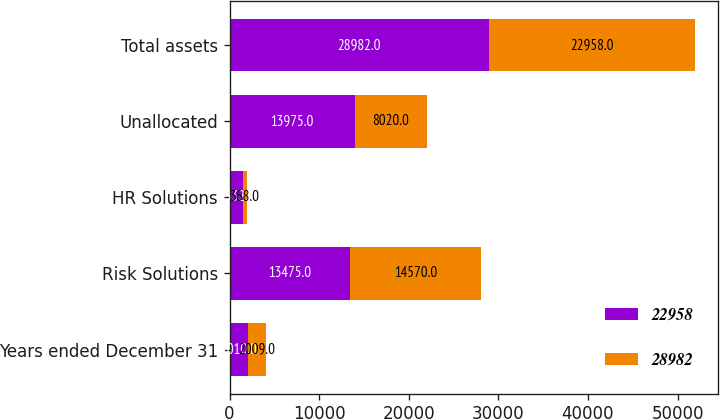Convert chart to OTSL. <chart><loc_0><loc_0><loc_500><loc_500><stacked_bar_chart><ecel><fcel>Years ended December 31<fcel>Risk Solutions<fcel>HR Solutions<fcel>Unallocated<fcel>Total assets<nl><fcel>22958<fcel>2010<fcel>13475<fcel>1532<fcel>13975<fcel>28982<nl><fcel>28982<fcel>2009<fcel>14570<fcel>368<fcel>8020<fcel>22958<nl></chart> 